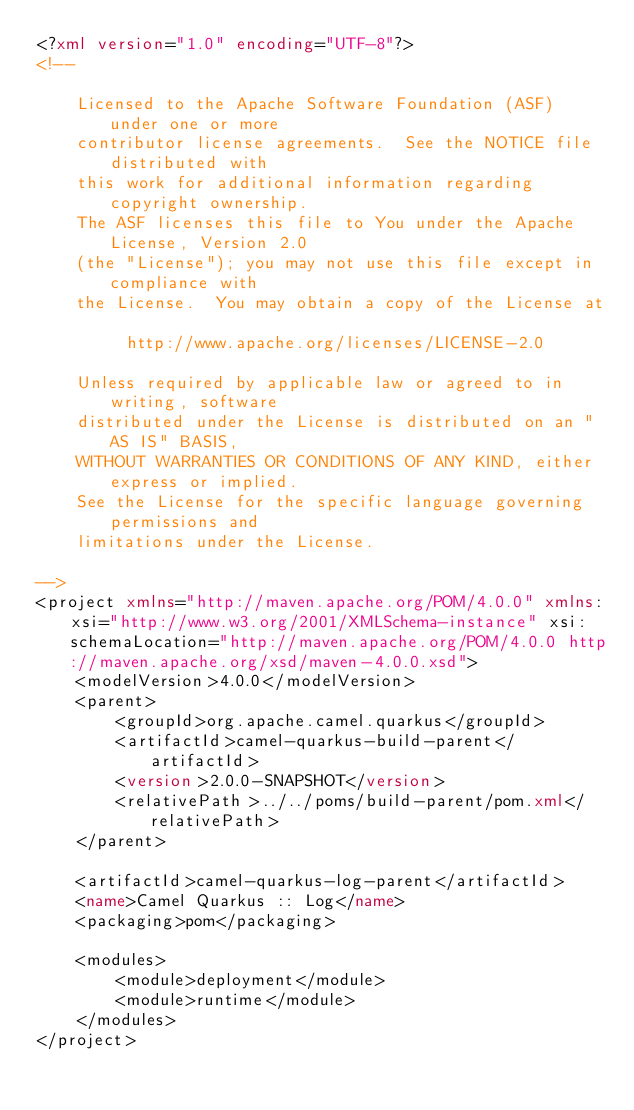<code> <loc_0><loc_0><loc_500><loc_500><_XML_><?xml version="1.0" encoding="UTF-8"?>
<!--

    Licensed to the Apache Software Foundation (ASF) under one or more
    contributor license agreements.  See the NOTICE file distributed with
    this work for additional information regarding copyright ownership.
    The ASF licenses this file to You under the Apache License, Version 2.0
    (the "License"); you may not use this file except in compliance with
    the License.  You may obtain a copy of the License at

         http://www.apache.org/licenses/LICENSE-2.0

    Unless required by applicable law or agreed to in writing, software
    distributed under the License is distributed on an "AS IS" BASIS,
    WITHOUT WARRANTIES OR CONDITIONS OF ANY KIND, either express or implied.
    See the License for the specific language governing permissions and
    limitations under the License.

-->
<project xmlns="http://maven.apache.org/POM/4.0.0" xmlns:xsi="http://www.w3.org/2001/XMLSchema-instance" xsi:schemaLocation="http://maven.apache.org/POM/4.0.0 http://maven.apache.org/xsd/maven-4.0.0.xsd">
    <modelVersion>4.0.0</modelVersion>
    <parent>
        <groupId>org.apache.camel.quarkus</groupId>
        <artifactId>camel-quarkus-build-parent</artifactId>
        <version>2.0.0-SNAPSHOT</version>
        <relativePath>../../poms/build-parent/pom.xml</relativePath>
    </parent>

    <artifactId>camel-quarkus-log-parent</artifactId>
    <name>Camel Quarkus :: Log</name>
    <packaging>pom</packaging>

    <modules>
        <module>deployment</module>
        <module>runtime</module>
    </modules>
</project>
</code> 